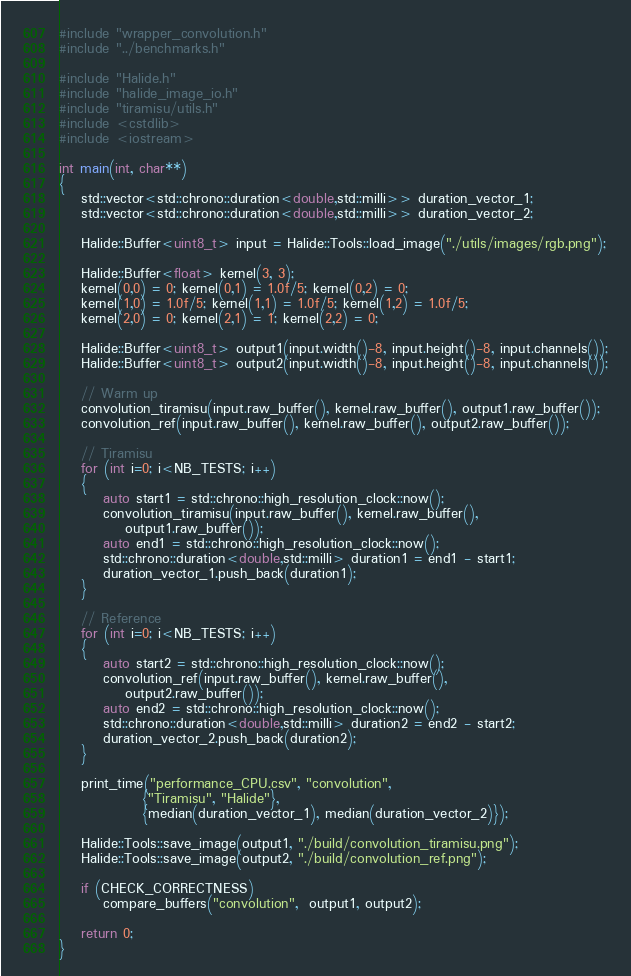Convert code to text. <code><loc_0><loc_0><loc_500><loc_500><_C++_>#include "wrapper_convolution.h"
#include "../benchmarks.h"

#include "Halide.h"
#include "halide_image_io.h"
#include "tiramisu/utils.h"
#include <cstdlib>
#include <iostream>

int main(int, char**)
{
    std::vector<std::chrono::duration<double,std::milli>> duration_vector_1;
    std::vector<std::chrono::duration<double,std::milli>> duration_vector_2;

    Halide::Buffer<uint8_t> input = Halide::Tools::load_image("./utils/images/rgb.png");

    Halide::Buffer<float> kernel(3, 3);
    kernel(0,0) = 0; kernel(0,1) = 1.0f/5; kernel(0,2) = 0;
    kernel(1,0) = 1.0f/5; kernel(1,1) = 1.0f/5; kernel(1,2) = 1.0f/5;
    kernel(2,0) = 0; kernel(2,1) = 1; kernel(2,2) = 0;

    Halide::Buffer<uint8_t> output1(input.width()-8, input.height()-8, input.channels());
    Halide::Buffer<uint8_t> output2(input.width()-8, input.height()-8, input.channels());

    // Warm up
    convolution_tiramisu(input.raw_buffer(), kernel.raw_buffer(), output1.raw_buffer());
    convolution_ref(input.raw_buffer(), kernel.raw_buffer(), output2.raw_buffer());

    // Tiramisu
    for (int i=0; i<NB_TESTS; i++)
    {
        auto start1 = std::chrono::high_resolution_clock::now();
        convolution_tiramisu(input.raw_buffer(), kernel.raw_buffer(),
			output1.raw_buffer());
        auto end1 = std::chrono::high_resolution_clock::now();
        std::chrono::duration<double,std::milli> duration1 = end1 - start1;
        duration_vector_1.push_back(duration1);
    }

    // Reference
    for (int i=0; i<NB_TESTS; i++)
    {
        auto start2 = std::chrono::high_resolution_clock::now();
        convolution_ref(input.raw_buffer(), kernel.raw_buffer(),
			output2.raw_buffer());
        auto end2 = std::chrono::high_resolution_clock::now();
        std::chrono::duration<double,std::milli> duration2 = end2 - start2;
        duration_vector_2.push_back(duration2);
    }

    print_time("performance_CPU.csv", "convolution",
               {"Tiramisu", "Halide"},
               {median(duration_vector_1), median(duration_vector_2)});

    Halide::Tools::save_image(output1, "./build/convolution_tiramisu.png");
    Halide::Tools::save_image(output2, "./build/convolution_ref.png");

    if (CHECK_CORRECTNESS)
        compare_buffers("convolution",  output1, output2);

    return 0;
}
</code> 